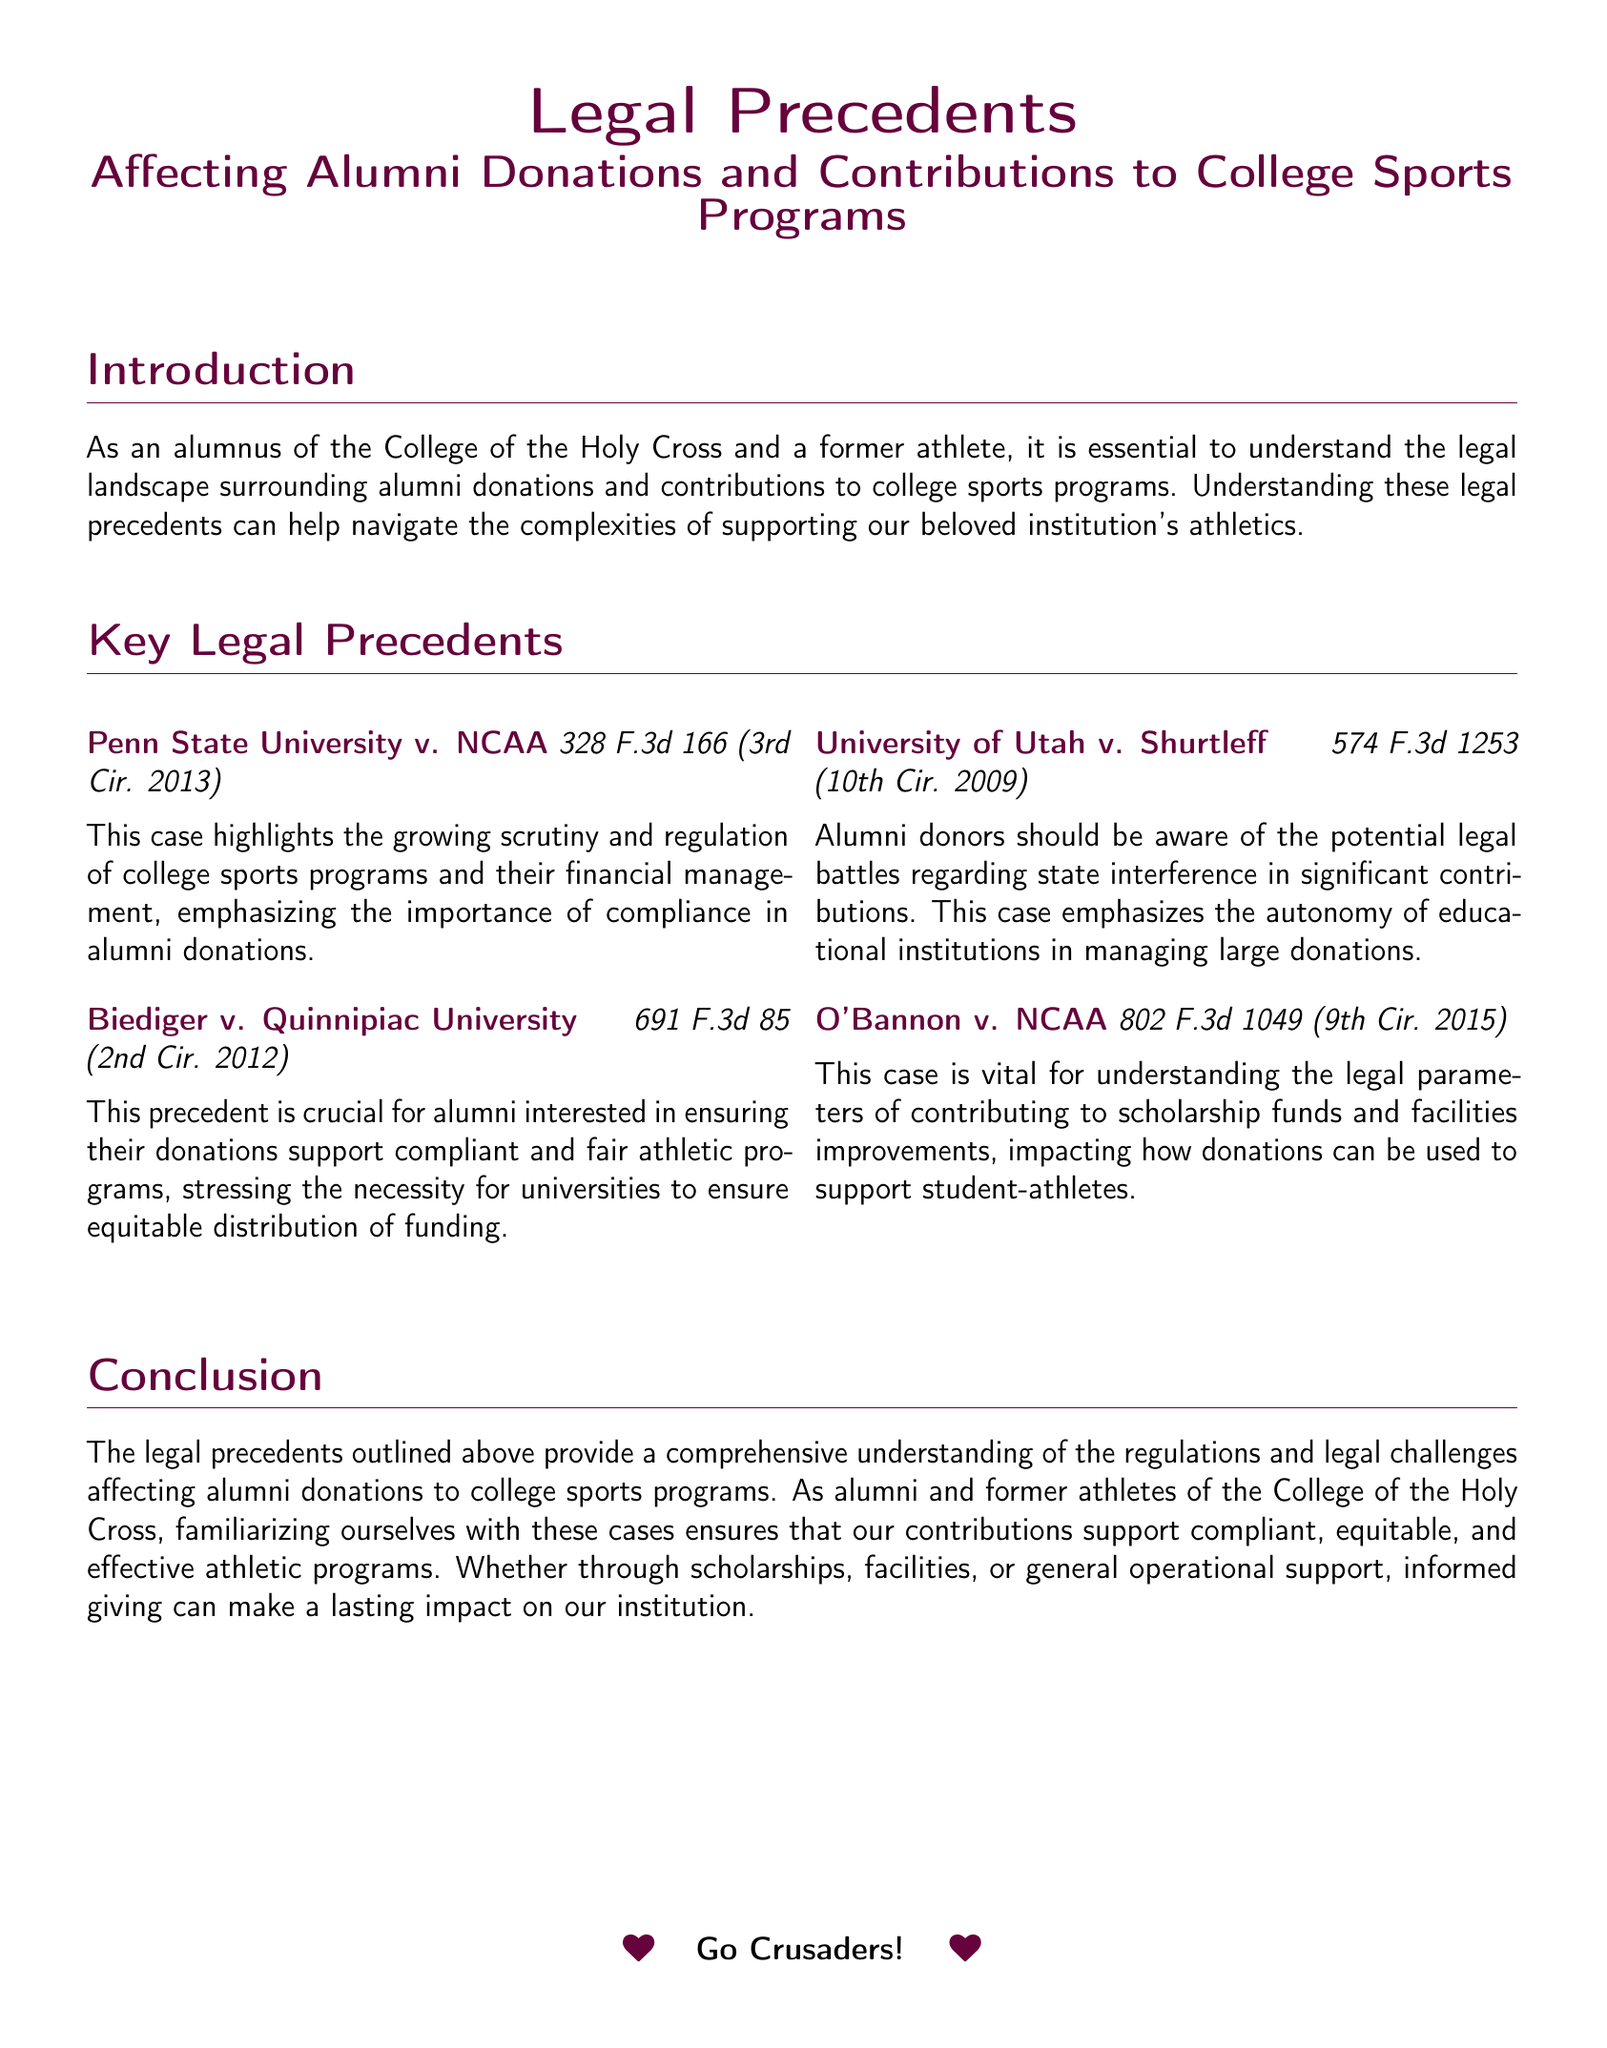What is the title of the legal brief? The title is located at the beginning of the document and summarizes the main topic.
Answer: Legal Precedents Affecting Alumni Donations and Contributions to College Sports Programs Who won the case in Penn State University v. NCAA? The document discusses the case but does not specify the winner; it provides an insight into its implications instead.
Answer: Not specified What year did the Biediger v. Quinnipiac University case occur? The case citation includes the year it was resolved, which provides context for the legal precedent.
Answer: 2012 What is the main concern highlighted in the University of Utah v. Shurtleff case? This case addresses the issue of state interference in significant contributions to educational institutions.
Answer: State interference What impact does the O'Bannon v. NCAA case have on donations? This case is specifically mentioned in relation to scholarship funds and facilities improvements, detailing its relevance to donor contributions.
Answer: Scholarships and facilities What color is prominently used in the document? The document includes color specifications for headings and sections, which enhances its visual appeal.
Answer: Purpleheart What should alumni familiarize themselves with, according to the conclusion? The conclusion emphasizes the importance of understanding legal precedents for informed giving to athletic programs.
Answer: Legal precedents What type of document is this? This document presents legal information specifically regarding alumni donations to college sports programs.
Answer: Legal brief What phrase is repeated in the document to show school spirit? The document includes a sentiment that reflects pride in the college and its athletic programs.
Answer: Go Crusaders! 